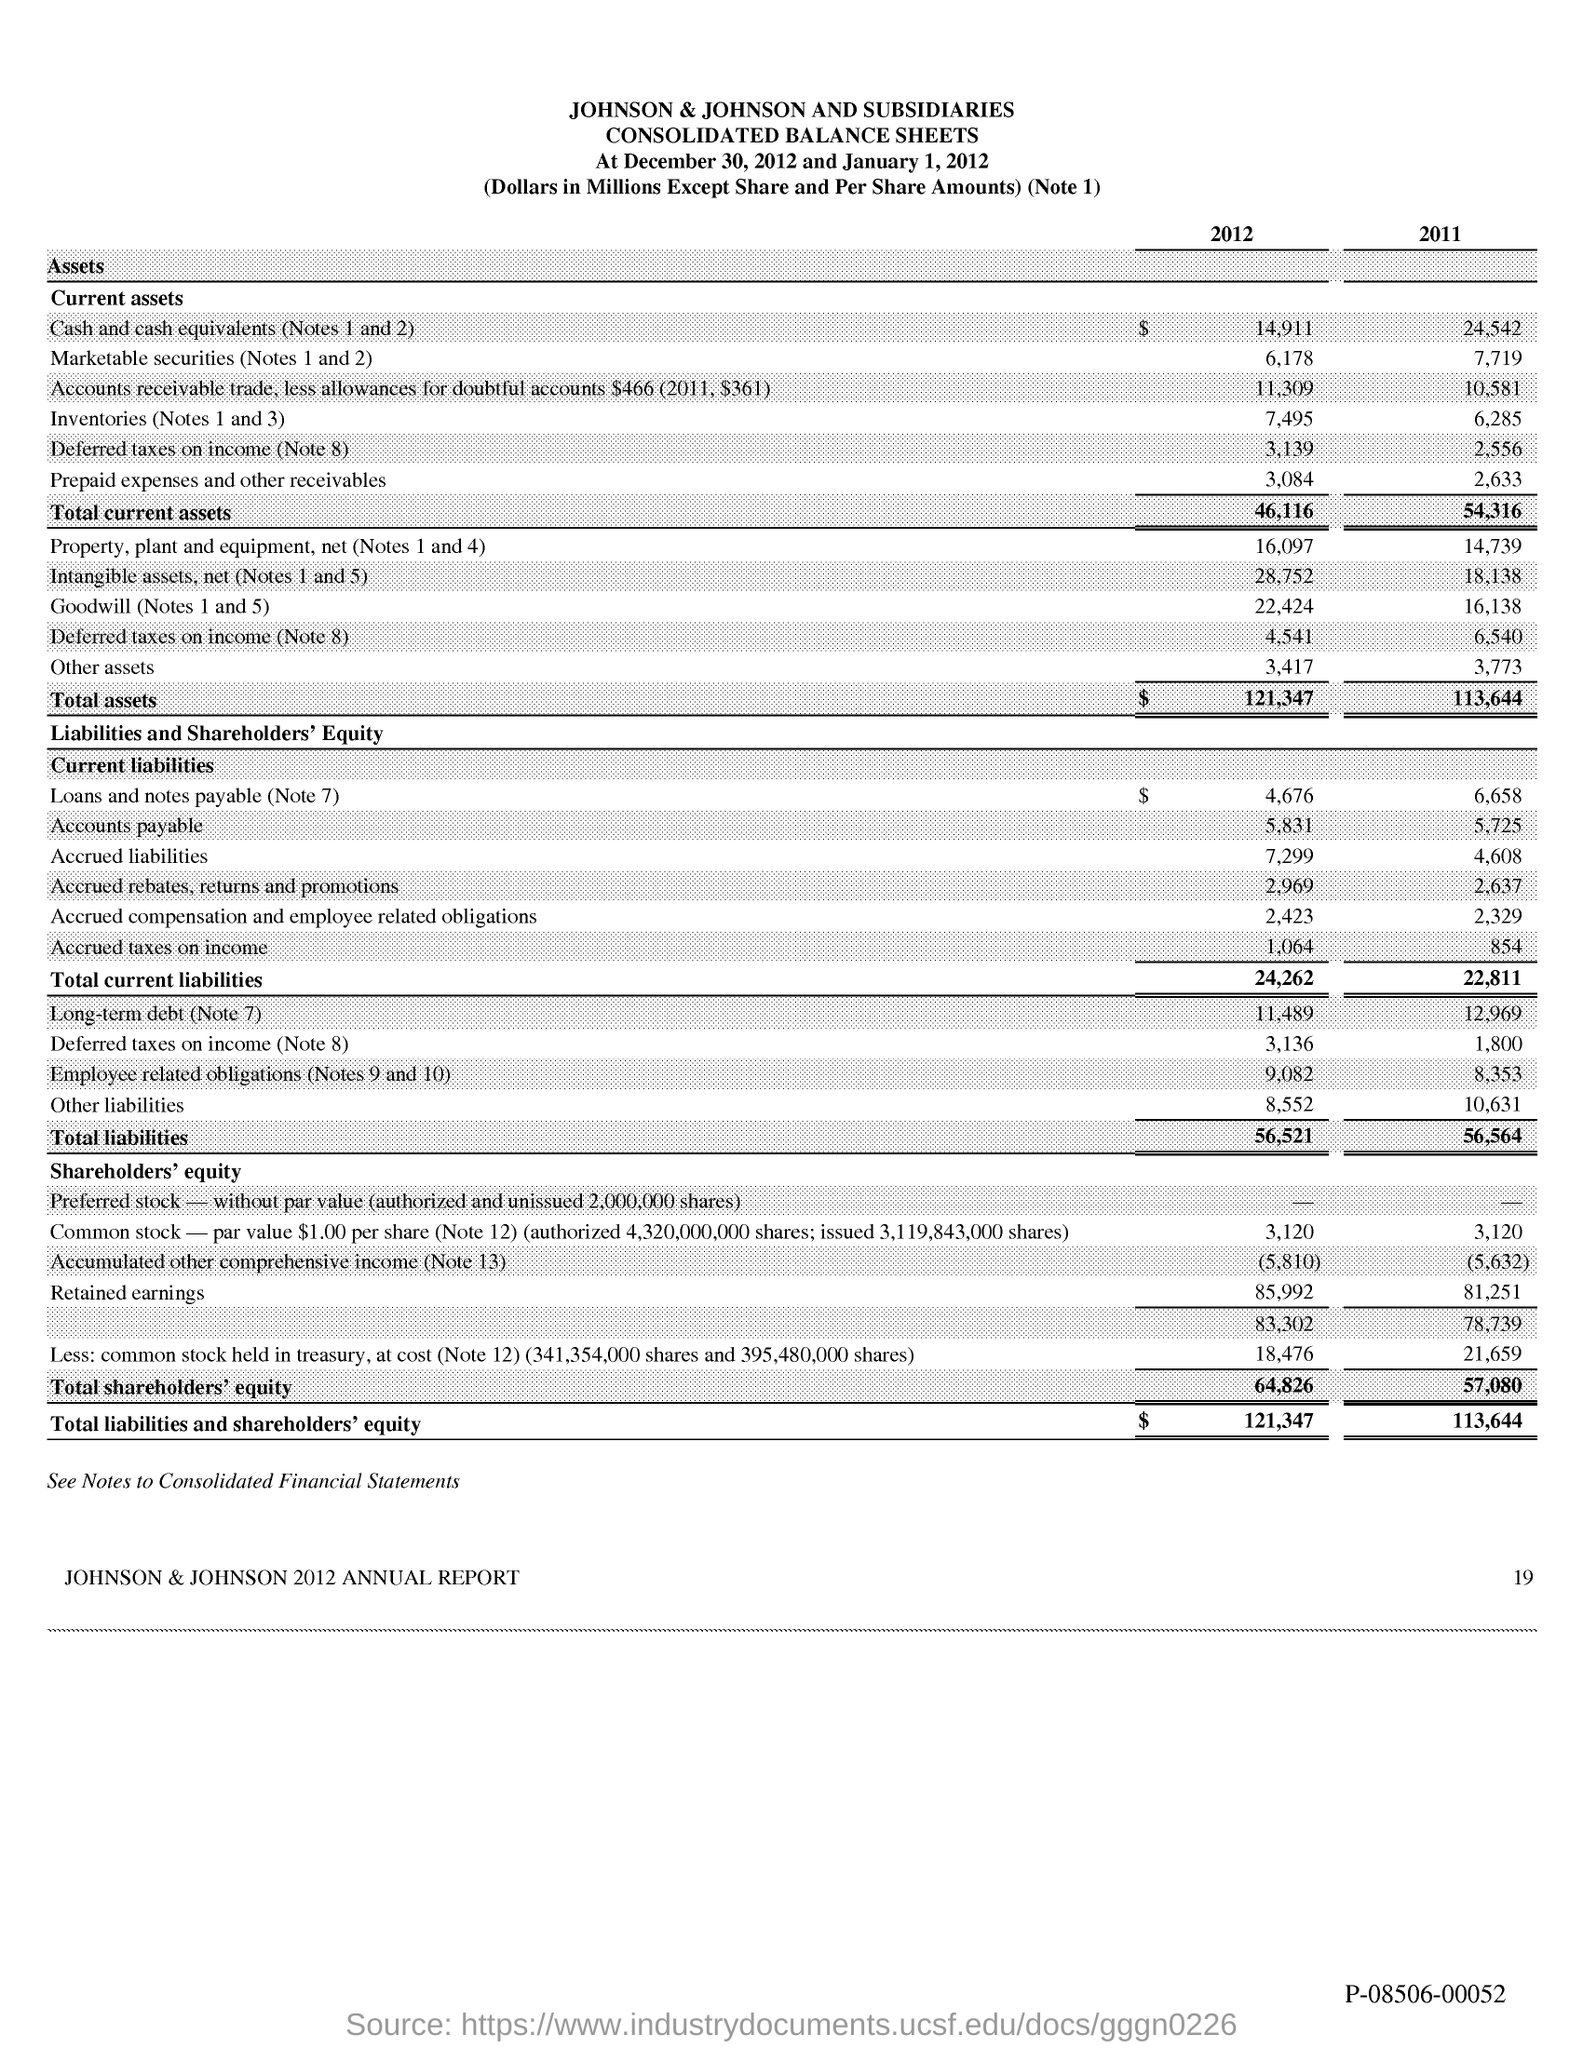What is the Page Number?
Offer a very short reply. 19. What is the total current assets in 2012?
Your response must be concise. 46,116. What is the total current assets in 2011?
Provide a short and direct response. 54,316. 